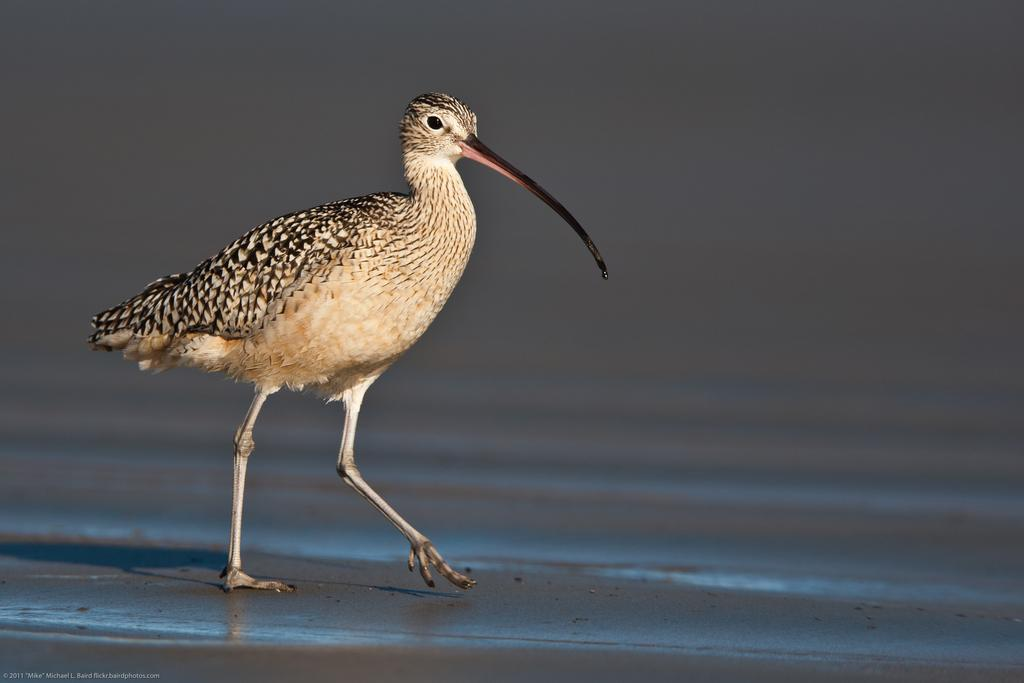What type of animal can be seen in the image? There is a bird in the image. Where is the bird located? The bird is on the land. How many eggs can be seen in the image? There are no eggs visible in the image; it only features a bird on the land. What type of tool is being used by the bird in the image? There is no tool, such as a wrench, present in the image. 